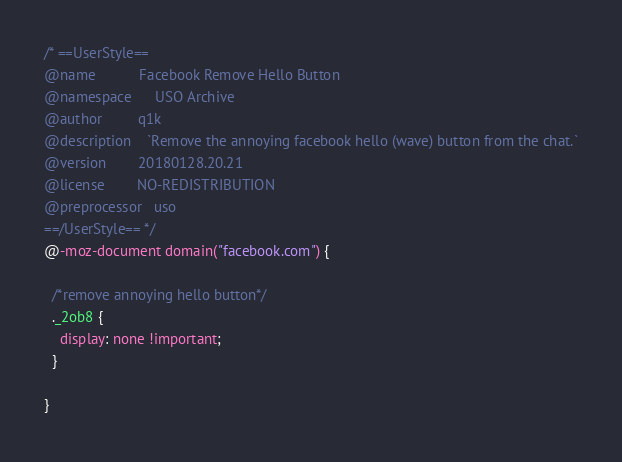Convert code to text. <code><loc_0><loc_0><loc_500><loc_500><_CSS_>/* ==UserStyle==
@name           Facebook Remove Hello Button
@namespace      USO Archive
@author         q1k
@description    `Remove the annoying facebook hello (wave) button from the chat.`
@version        20180128.20.21
@license        NO-REDISTRIBUTION
@preprocessor   uso
==/UserStyle== */
@-moz-document domain("facebook.com") {
  
  /*remove annoying hello button*/
  ._2ob8 {
    display: none !important;
  }
  
}
</code> 